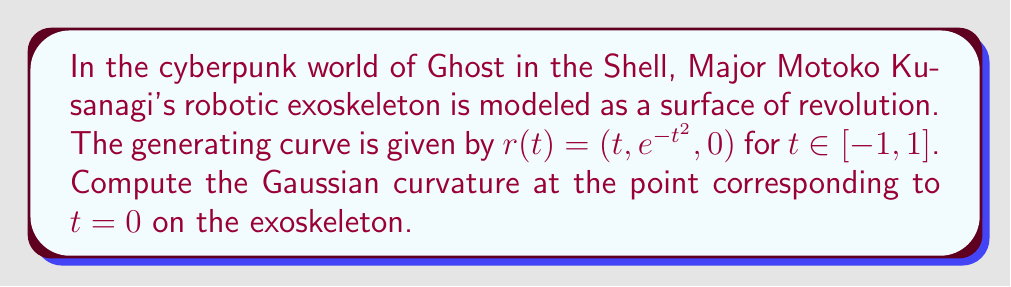Teach me how to tackle this problem. To compute the Gaussian curvature of Major Kusanagi's exoskeleton, we'll follow these steps:

1) For a surface of revolution with generating curve $r(t) = (f(t), g(t), 0)$, the parametrization is:
   $$X(t, \theta) = (f(t), g(t)\cos\theta, g(t)\sin\theta)$$

2) The first fundamental form coefficients are:
   $$E = \langle X_t, X_t \rangle = f'^2 + g'^2$$
   $$F = \langle X_t, X_\theta \rangle = 0$$
   $$G = \langle X_\theta, X_\theta \rangle = g^2$$

3) The second fundamental form coefficients are:
   $$L = \frac{f'g'' - f''g'}{\sqrt{f'^2 + g'^2}}$$
   $$M = 0$$
   $$N = \frac{fg'}{\sqrt{f'^2 + g'^2}}$$

4) The Gaussian curvature is given by:
   $$K = \frac{LN - M^2}{EG - F^2} = \frac{LN}{EG}$$

5) For our curve, $f(t) = t$ and $g(t) = e^{-t^2}$. At $t = 0$:
   $f(0) = 0$, $g(0) = 1$
   $f'(0) = 1$, $g'(0) = 0$
   $f''(0) = 0$, $g''(0) = -2$

6) Calculating E, G, L, and N at $t = 0$:
   $E = f'^2 + g'^2 = 1^2 + 0^2 = 1$
   $G = g^2 = 1^2 = 1$
   $L = \frac{f'g'' - f''g'}{\sqrt{f'^2 + g'^2}} = \frac{1(-2) - 0(0)}{\sqrt{1^2 + 0^2}} = -2$
   $N = \frac{fg'}{\sqrt{f'^2 + g'^2}} = \frac{0(0)}{\sqrt{1^2 + 0^2}} = 0$

7) Finally, we can compute the Gaussian curvature:
   $$K = \frac{LN}{EG} = \frac{(-2)(0)}{(1)(1)} = 0$$

Therefore, the Gaussian curvature at the point corresponding to $t = 0$ on Major Kusanagi's exoskeleton is 0.
Answer: $K = 0$ 